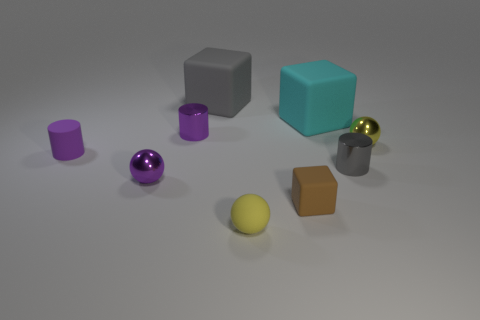Is the material of the tiny thing that is in front of the small brown block the same as the tiny gray cylinder?
Offer a very short reply. No. Is the number of big things right of the small brown block less than the number of yellow spheres?
Keep it short and to the point. Yes. The purple object that is left of the small purple ball has what shape?
Provide a succinct answer. Cylinder. There is a brown object that is the same size as the rubber cylinder; what shape is it?
Offer a terse response. Cube. Are there any tiny purple objects of the same shape as the tiny brown rubber thing?
Your answer should be very brief. No. There is a shiny object in front of the tiny gray thing; is it the same shape as the small yellow object in front of the tiny yellow shiny ball?
Ensure brevity in your answer.  Yes. What material is the gray object that is the same size as the purple sphere?
Your answer should be compact. Metal. What number of other things are there of the same material as the large gray thing
Offer a terse response. 4. There is a large object that is behind the large cyan rubber thing behind the brown thing; what is its shape?
Provide a succinct answer. Cube. What number of objects are either yellow things or yellow things to the right of the big cyan thing?
Provide a succinct answer. 2. 